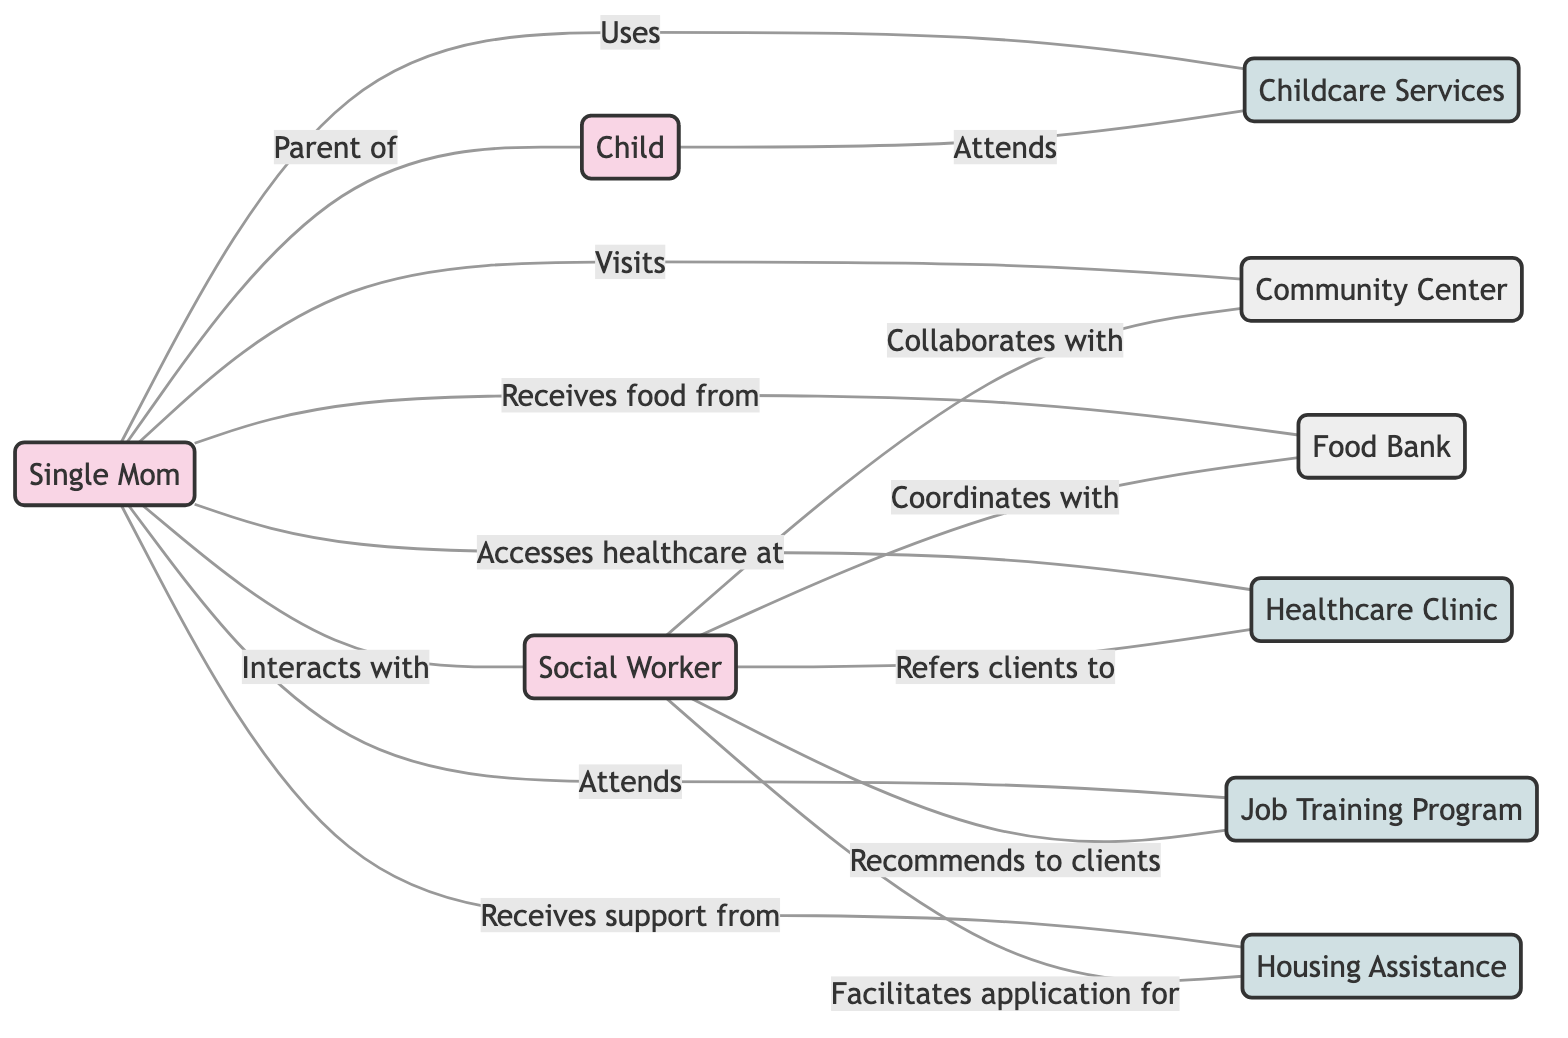What is the total number of nodes in the graph? The graph includes nine unique entities, where the nodes are Single Mom, Child, Social Worker, Community Center, Food Bank, Healthcare Clinic, Job Training Program, Childcare Services, and Housing Assistance.
Answer: 9 Which resource does the Single Mom receive food from? The diagram indicates a direct relationship from the Single Mom to the Food Bank labeled "Receives food from," showing the connection between them.
Answer: Food Bank What relationship does the Social Worker have with the Community Center? The edge between the Social Worker and the Community Center is labeled "Collaborates with," indicating their interaction in terms of mutual support.
Answer: Collaborates with How many services does the Single Mom use? The edges connecting the Single Mom to Childcare Services, Healthcare Clinic, Job Training Program, and Housing Assistance collectively represent four services that she uses, thus totaling four.
Answer: 4 Which services does the Social Worker refer clients to? The Social Worker has an edge leading to the Healthcare Clinic, and the edge is specified as "Refers clients to," indicating the direct advising relationship.
Answer: Healthcare Clinic What is the connection between the Child and Childcare Services? The edge connecting Child to Childcare Services is labeled "Attends," specifying that the Child participates in the Childcare Services provided.
Answer: Attends Which entity does the Social Worker coordinate with? According to the edges in the diagram, the Social Worker has an edge leading to the Food Bank, which is labeled "Coordinates with," designating their relationship.
Answer: Food Bank How does the Single Mom access healthcare? The edge from the Single Mom to the Healthcare Clinic is labeled "Accesses healthcare at," indicating the way she obtains medical services.
Answer: Healthcare Clinic What role does the Social Worker play in relation to Housing Assistance? The diagram shows an edge between the Social Worker and Housing Assistance labeled "Facilitates application for," implying that the Social Worker helps with the application process.
Answer: Facilitates application for 